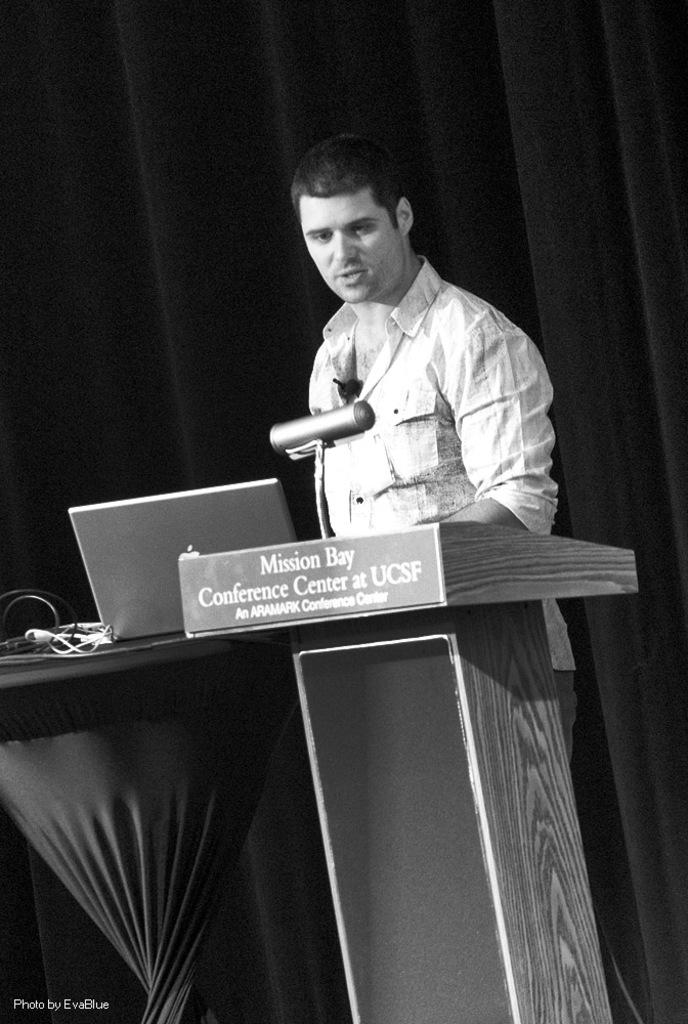What is the main subject of the image? There is a man standing in the image. What object is present on the table in the image? There is a laptop on the table. What is the color or lighting condition of the background in the image? The background of the image is dark. Can you see a woman or a yak in the image? No, there is no woman or yak present in the image. Is the man in the image in jail? There is no indication in the image that the man is in jail. 